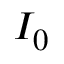<formula> <loc_0><loc_0><loc_500><loc_500>I _ { 0 }</formula> 